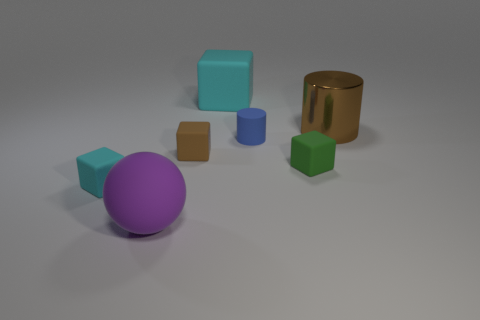What can you infer about the textures in this image? The objects exhibit different textures: the sphere and some cubes have a smooth and shiny surface, reflecting some light, indicating they may be made of plastic or polished stone. The brown cube and the blue cylinder have a matte finish, giving them a soft, non-reflective appearance that suggests a more porous material like wood or stone. 